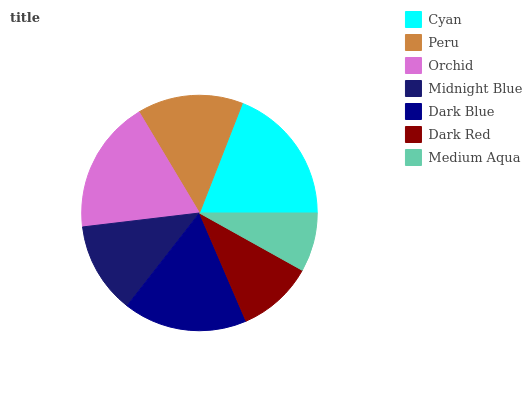Is Medium Aqua the minimum?
Answer yes or no. Yes. Is Cyan the maximum?
Answer yes or no. Yes. Is Peru the minimum?
Answer yes or no. No. Is Peru the maximum?
Answer yes or no. No. Is Cyan greater than Peru?
Answer yes or no. Yes. Is Peru less than Cyan?
Answer yes or no. Yes. Is Peru greater than Cyan?
Answer yes or no. No. Is Cyan less than Peru?
Answer yes or no. No. Is Peru the high median?
Answer yes or no. Yes. Is Peru the low median?
Answer yes or no. Yes. Is Orchid the high median?
Answer yes or no. No. Is Orchid the low median?
Answer yes or no. No. 